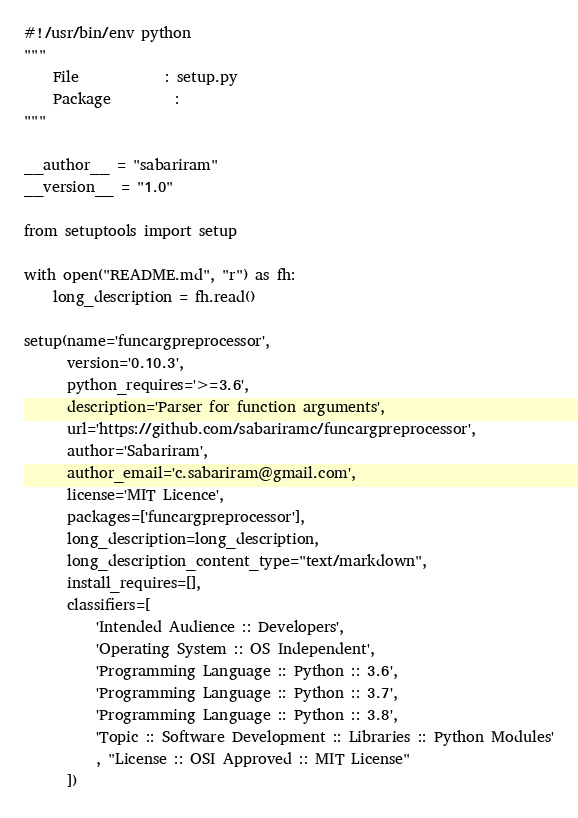<code> <loc_0><loc_0><loc_500><loc_500><_Python_>#!/usr/bin/env python
"""
    File            : setup.py
    Package         :
"""

__author__ = "sabariram"
__version__ = "1.0"

from setuptools import setup

with open("README.md", "r") as fh:
    long_description = fh.read()

setup(name='funcargpreprocessor',
      version='0.10.3',
      python_requires='>=3.6',
      description='Parser for function arguments',
      url='https://github.com/sabariramc/funcargpreprocessor',
      author='Sabariram',
      author_email='c.sabariram@gmail.com',
      license='MIT Licence',
      packages=['funcargpreprocessor'],
      long_description=long_description,
      long_description_content_type="text/markdown",
      install_requires=[],
      classifiers=[
          'Intended Audience :: Developers',
          'Operating System :: OS Independent',
          'Programming Language :: Python :: 3.6',
          'Programming Language :: Python :: 3.7',
          'Programming Language :: Python :: 3.8',
          'Topic :: Software Development :: Libraries :: Python Modules'
          , "License :: OSI Approved :: MIT License"
      ])
</code> 